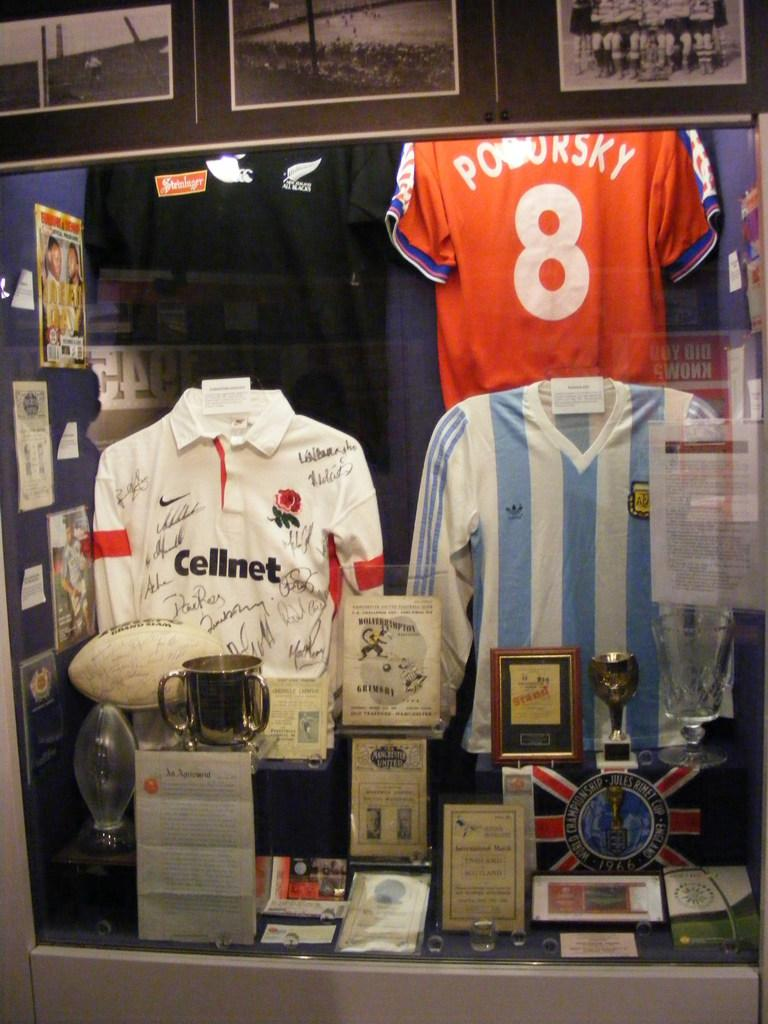<image>
Summarize the visual content of the image. An orange jersey with the number 8 on it is hanging in a display window. 